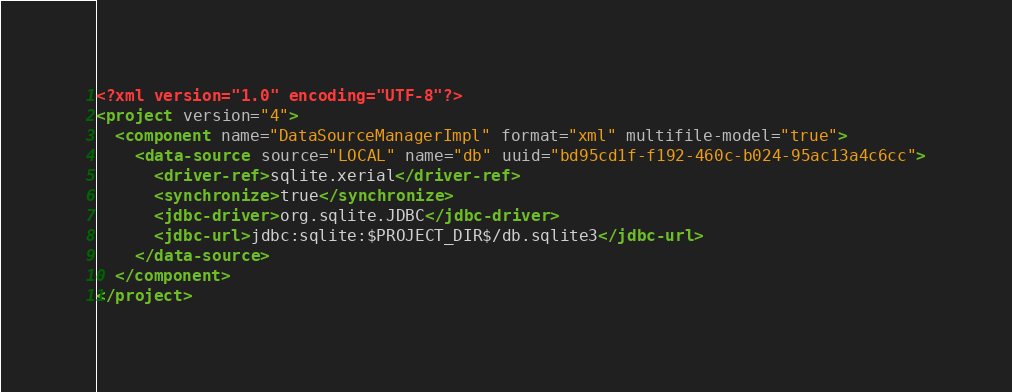<code> <loc_0><loc_0><loc_500><loc_500><_XML_><?xml version="1.0" encoding="UTF-8"?>
<project version="4">
  <component name="DataSourceManagerImpl" format="xml" multifile-model="true">
    <data-source source="LOCAL" name="db" uuid="bd95cd1f-f192-460c-b024-95ac13a4c6cc">
      <driver-ref>sqlite.xerial</driver-ref>
      <synchronize>true</synchronize>
      <jdbc-driver>org.sqlite.JDBC</jdbc-driver>
      <jdbc-url>jdbc:sqlite:$PROJECT_DIR$/db.sqlite3</jdbc-url>
    </data-source>
  </component>
</project></code> 